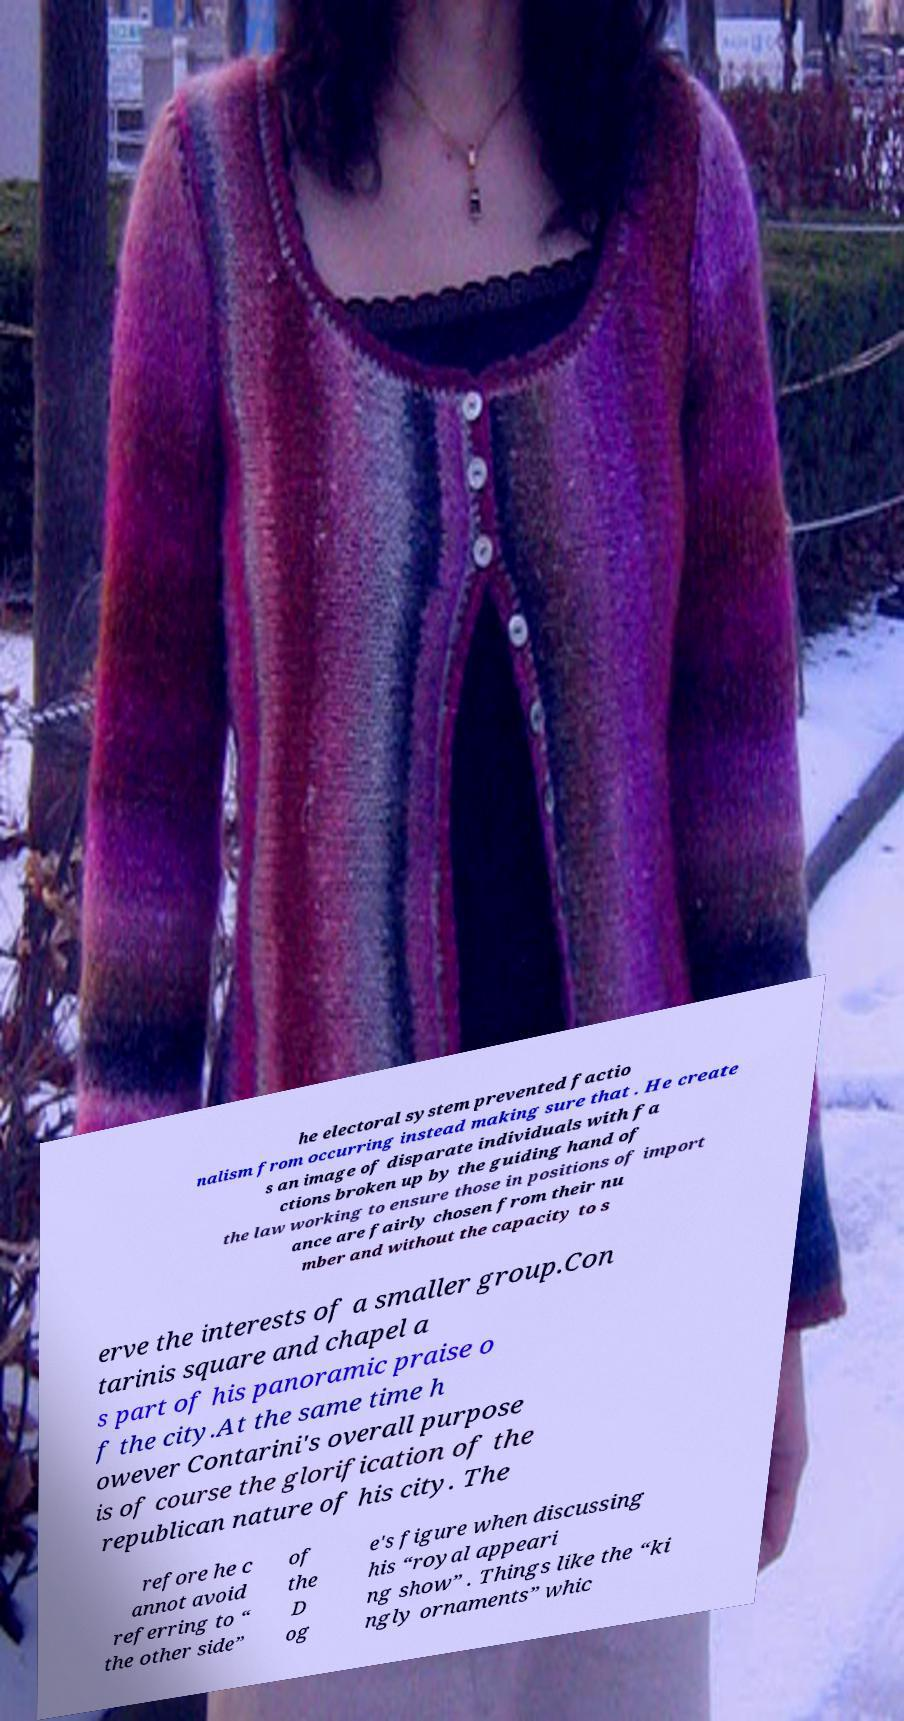There's text embedded in this image that I need extracted. Can you transcribe it verbatim? he electoral system prevented factio nalism from occurring instead making sure that . He create s an image of disparate individuals with fa ctions broken up by the guiding hand of the law working to ensure those in positions of import ance are fairly chosen from their nu mber and without the capacity to s erve the interests of a smaller group.Con tarinis square and chapel a s part of his panoramic praise o f the city.At the same time h owever Contarini's overall purpose is of course the glorification of the republican nature of his city. The refore he c annot avoid referring to “ the other side” of the D og e's figure when discussing his “royal appeari ng show” . Things like the “ki ngly ornaments” whic 